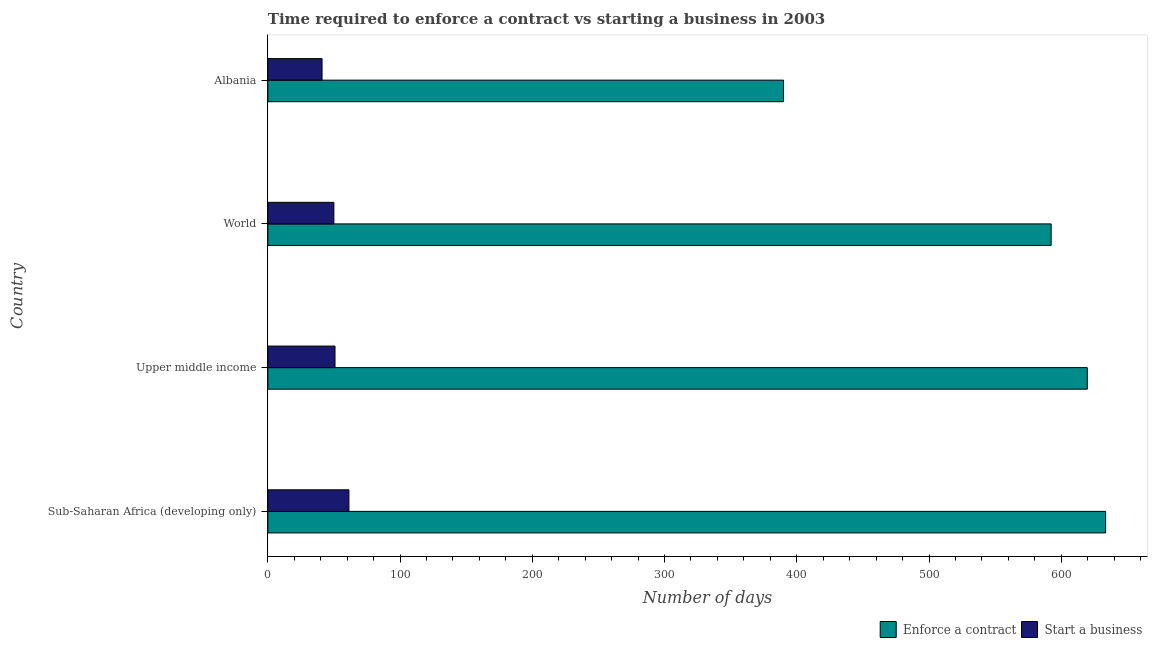How many groups of bars are there?
Keep it short and to the point. 4. Are the number of bars per tick equal to the number of legend labels?
Make the answer very short. Yes. How many bars are there on the 3rd tick from the bottom?
Your answer should be compact. 2. What is the label of the 3rd group of bars from the top?
Offer a very short reply. Upper middle income. In how many cases, is the number of bars for a given country not equal to the number of legend labels?
Provide a short and direct response. 0. What is the number of days to enforece a contract in Upper middle income?
Offer a terse response. 619.71. Across all countries, what is the maximum number of days to start a business?
Give a very brief answer. 61.31. Across all countries, what is the minimum number of days to enforece a contract?
Your response must be concise. 390. In which country was the number of days to enforece a contract maximum?
Your response must be concise. Sub-Saharan Africa (developing only). In which country was the number of days to enforece a contract minimum?
Ensure brevity in your answer.  Albania. What is the total number of days to start a business in the graph?
Offer a terse response. 203.05. What is the difference between the number of days to enforece a contract in Albania and that in World?
Make the answer very short. -202.38. What is the difference between the number of days to start a business in Albania and the number of days to enforece a contract in Upper middle income?
Your response must be concise. -578.71. What is the average number of days to start a business per country?
Your response must be concise. 50.76. What is the difference between the number of days to enforece a contract and number of days to start a business in Upper middle income?
Offer a very short reply. 568.91. In how many countries, is the number of days to enforece a contract greater than 580 days?
Provide a succinct answer. 3. What is the ratio of the number of days to start a business in Sub-Saharan Africa (developing only) to that in World?
Offer a terse response. 1.23. Is the number of days to enforece a contract in Upper middle income less than that in World?
Your response must be concise. No. Is the difference between the number of days to start a business in Albania and Upper middle income greater than the difference between the number of days to enforece a contract in Albania and Upper middle income?
Your response must be concise. Yes. What is the difference between the highest and the second highest number of days to enforece a contract?
Your answer should be very brief. 13.85. What is the difference between the highest and the lowest number of days to enforece a contract?
Your answer should be very brief. 243.56. What does the 2nd bar from the top in Sub-Saharan Africa (developing only) represents?
Give a very brief answer. Enforce a contract. What does the 2nd bar from the bottom in World represents?
Give a very brief answer. Start a business. How many bars are there?
Your answer should be compact. 8. How many countries are there in the graph?
Your answer should be very brief. 4. Does the graph contain any zero values?
Keep it short and to the point. No. Where does the legend appear in the graph?
Your answer should be compact. Bottom right. How are the legend labels stacked?
Offer a terse response. Horizontal. What is the title of the graph?
Your answer should be very brief. Time required to enforce a contract vs starting a business in 2003. What is the label or title of the X-axis?
Ensure brevity in your answer.  Number of days. What is the label or title of the Y-axis?
Give a very brief answer. Country. What is the Number of days of Enforce a contract in Sub-Saharan Africa (developing only)?
Offer a terse response. 633.56. What is the Number of days in Start a business in Sub-Saharan Africa (developing only)?
Your response must be concise. 61.31. What is the Number of days of Enforce a contract in Upper middle income?
Provide a short and direct response. 619.71. What is the Number of days of Start a business in Upper middle income?
Keep it short and to the point. 50.8. What is the Number of days in Enforce a contract in World?
Your answer should be compact. 592.38. What is the Number of days in Start a business in World?
Give a very brief answer. 49.94. What is the Number of days in Enforce a contract in Albania?
Provide a short and direct response. 390. Across all countries, what is the maximum Number of days of Enforce a contract?
Your answer should be compact. 633.56. Across all countries, what is the maximum Number of days in Start a business?
Keep it short and to the point. 61.31. Across all countries, what is the minimum Number of days in Enforce a contract?
Provide a succinct answer. 390. Across all countries, what is the minimum Number of days of Start a business?
Provide a succinct answer. 41. What is the total Number of days in Enforce a contract in the graph?
Your answer should be compact. 2235.66. What is the total Number of days of Start a business in the graph?
Offer a very short reply. 203.05. What is the difference between the Number of days in Enforce a contract in Sub-Saharan Africa (developing only) and that in Upper middle income?
Give a very brief answer. 13.85. What is the difference between the Number of days in Start a business in Sub-Saharan Africa (developing only) and that in Upper middle income?
Your answer should be very brief. 10.51. What is the difference between the Number of days in Enforce a contract in Sub-Saharan Africa (developing only) and that in World?
Ensure brevity in your answer.  41.18. What is the difference between the Number of days in Start a business in Sub-Saharan Africa (developing only) and that in World?
Your answer should be compact. 11.38. What is the difference between the Number of days of Enforce a contract in Sub-Saharan Africa (developing only) and that in Albania?
Your response must be concise. 243.56. What is the difference between the Number of days of Start a business in Sub-Saharan Africa (developing only) and that in Albania?
Provide a short and direct response. 20.31. What is the difference between the Number of days of Enforce a contract in Upper middle income and that in World?
Offer a terse response. 27.33. What is the difference between the Number of days of Start a business in Upper middle income and that in World?
Provide a short and direct response. 0.86. What is the difference between the Number of days in Enforce a contract in Upper middle income and that in Albania?
Provide a short and direct response. 229.71. What is the difference between the Number of days of Start a business in Upper middle income and that in Albania?
Your answer should be very brief. 9.8. What is the difference between the Number of days in Enforce a contract in World and that in Albania?
Provide a succinct answer. 202.38. What is the difference between the Number of days in Start a business in World and that in Albania?
Your response must be concise. 8.94. What is the difference between the Number of days in Enforce a contract in Sub-Saharan Africa (developing only) and the Number of days in Start a business in Upper middle income?
Offer a very short reply. 582.76. What is the difference between the Number of days in Enforce a contract in Sub-Saharan Africa (developing only) and the Number of days in Start a business in World?
Your answer should be compact. 583.63. What is the difference between the Number of days in Enforce a contract in Sub-Saharan Africa (developing only) and the Number of days in Start a business in Albania?
Make the answer very short. 592.56. What is the difference between the Number of days in Enforce a contract in Upper middle income and the Number of days in Start a business in World?
Make the answer very short. 569.78. What is the difference between the Number of days of Enforce a contract in Upper middle income and the Number of days of Start a business in Albania?
Your answer should be very brief. 578.71. What is the difference between the Number of days of Enforce a contract in World and the Number of days of Start a business in Albania?
Keep it short and to the point. 551.38. What is the average Number of days in Enforce a contract per country?
Make the answer very short. 558.91. What is the average Number of days of Start a business per country?
Your answer should be very brief. 50.76. What is the difference between the Number of days of Enforce a contract and Number of days of Start a business in Sub-Saharan Africa (developing only)?
Ensure brevity in your answer.  572.25. What is the difference between the Number of days of Enforce a contract and Number of days of Start a business in Upper middle income?
Keep it short and to the point. 568.91. What is the difference between the Number of days in Enforce a contract and Number of days in Start a business in World?
Keep it short and to the point. 542.44. What is the difference between the Number of days in Enforce a contract and Number of days in Start a business in Albania?
Offer a very short reply. 349. What is the ratio of the Number of days in Enforce a contract in Sub-Saharan Africa (developing only) to that in Upper middle income?
Your answer should be compact. 1.02. What is the ratio of the Number of days in Start a business in Sub-Saharan Africa (developing only) to that in Upper middle income?
Provide a succinct answer. 1.21. What is the ratio of the Number of days of Enforce a contract in Sub-Saharan Africa (developing only) to that in World?
Your answer should be compact. 1.07. What is the ratio of the Number of days in Start a business in Sub-Saharan Africa (developing only) to that in World?
Offer a terse response. 1.23. What is the ratio of the Number of days of Enforce a contract in Sub-Saharan Africa (developing only) to that in Albania?
Provide a short and direct response. 1.62. What is the ratio of the Number of days in Start a business in Sub-Saharan Africa (developing only) to that in Albania?
Ensure brevity in your answer.  1.5. What is the ratio of the Number of days in Enforce a contract in Upper middle income to that in World?
Ensure brevity in your answer.  1.05. What is the ratio of the Number of days of Start a business in Upper middle income to that in World?
Keep it short and to the point. 1.02. What is the ratio of the Number of days of Enforce a contract in Upper middle income to that in Albania?
Offer a very short reply. 1.59. What is the ratio of the Number of days in Start a business in Upper middle income to that in Albania?
Your answer should be very brief. 1.24. What is the ratio of the Number of days of Enforce a contract in World to that in Albania?
Your response must be concise. 1.52. What is the ratio of the Number of days of Start a business in World to that in Albania?
Provide a succinct answer. 1.22. What is the difference between the highest and the second highest Number of days in Enforce a contract?
Ensure brevity in your answer.  13.85. What is the difference between the highest and the second highest Number of days in Start a business?
Your response must be concise. 10.51. What is the difference between the highest and the lowest Number of days of Enforce a contract?
Your response must be concise. 243.56. What is the difference between the highest and the lowest Number of days in Start a business?
Offer a terse response. 20.31. 